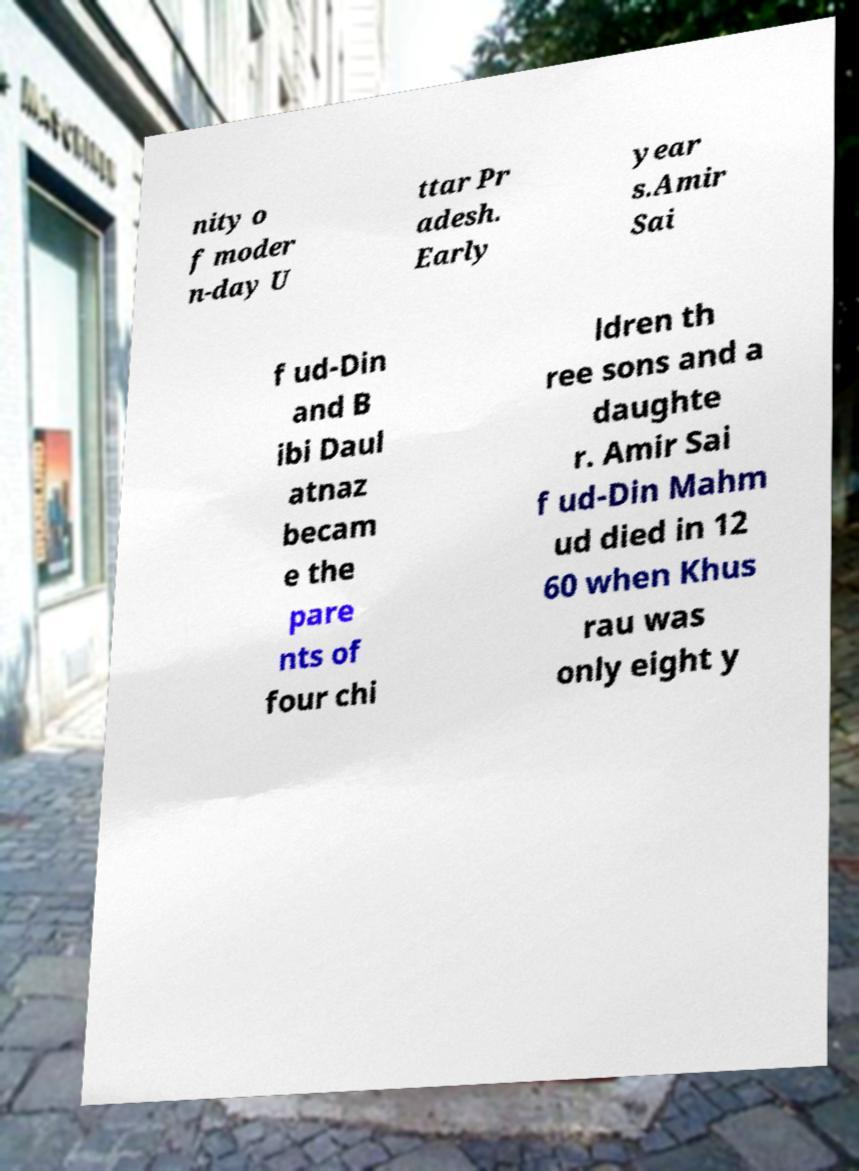I need the written content from this picture converted into text. Can you do that? nity o f moder n-day U ttar Pr adesh. Early year s.Amir Sai f ud-Din and B ibi Daul atnaz becam e the pare nts of four chi ldren th ree sons and a daughte r. Amir Sai f ud-Din Mahm ud died in 12 60 when Khus rau was only eight y 